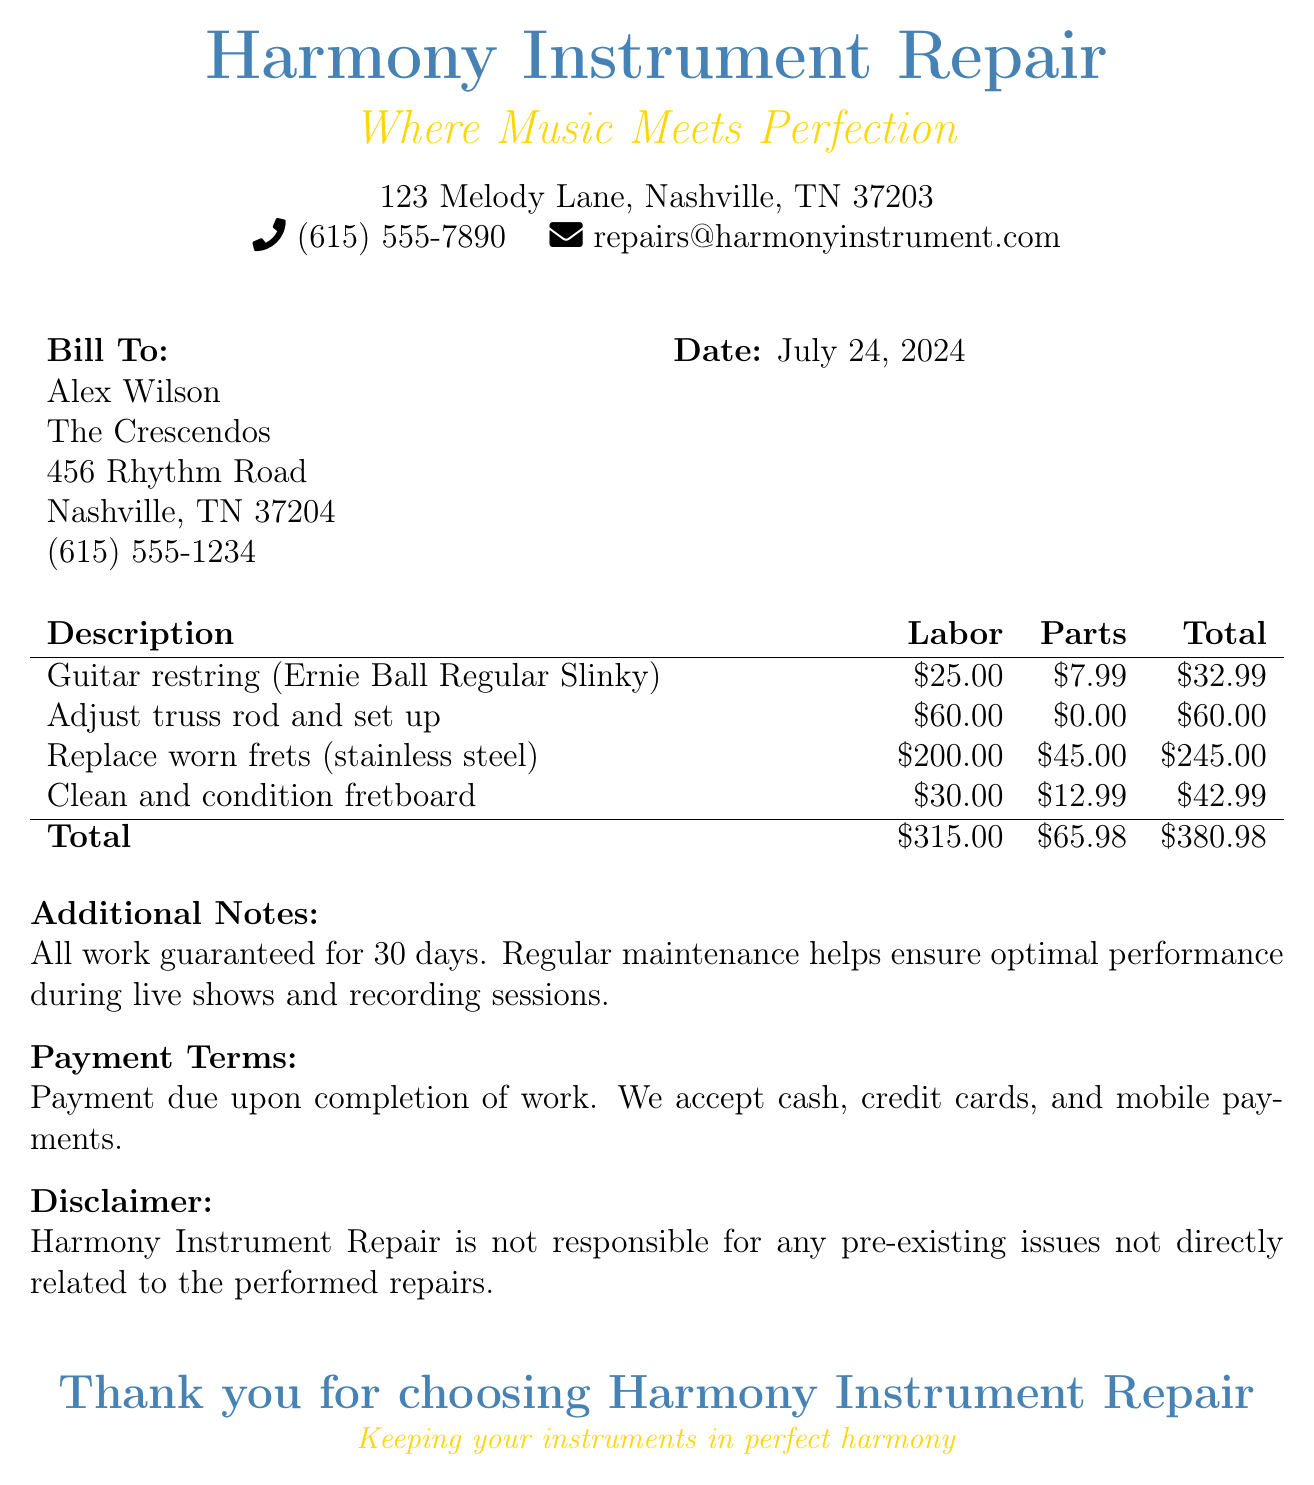What is the total amount due? The total amount due is found in the totals section of the bill, which sums up labor and parts charges.
Answer: $380.98 Who is the bill addressed to? The bill lists the name of the individual it's addressed to at the top, under "Bill To."
Answer: Alex Wilson What is the phone number for Harmony Instrument Repair? The contact information is provided at the beginning of the document, stating the phone number.
Answer: (615) 555-7890 How much was charged for labor on replacing worn frets? The specific labor charge for that service can be found in the description section.
Answer: $200.00 What is the name of the business? The name of the business is prominently displayed at the top of the document.
Answer: Harmony Instrument Repair What parts were used for the guitar restring? The parts cost associated with the restring service is indicated next to the description.
Answer: $7.99 How long is the work guaranteed for? The guarantee period is mentioned in the additional notes section of the bill.
Answer: 30 days What is the payment term stated in the document? The payment terms are provided towards the end of the document, specifying the timing of payment.
Answer: Payment due upon completion of work 